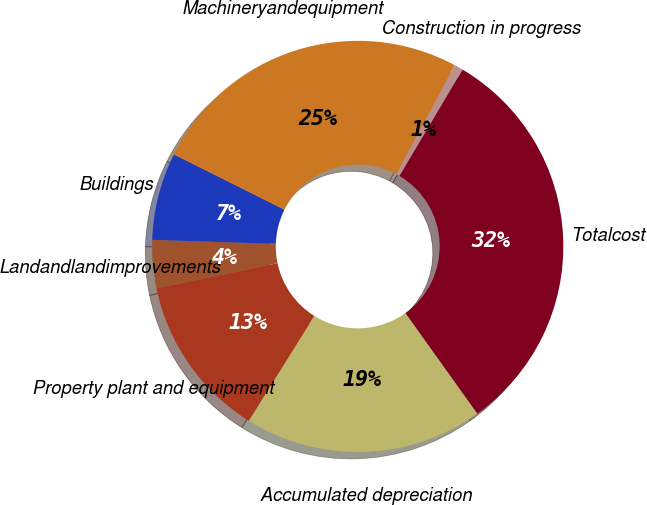Convert chart to OTSL. <chart><loc_0><loc_0><loc_500><loc_500><pie_chart><fcel>Landandlandimprovements<fcel>Buildings<fcel>Machineryandequipment<fcel>Construction in progress<fcel>Totalcost<fcel>Accumulated depreciation<fcel>Property plant and equipment<nl><fcel>3.78%<fcel>6.87%<fcel>25.45%<fcel>0.69%<fcel>31.6%<fcel>18.76%<fcel>12.84%<nl></chart> 